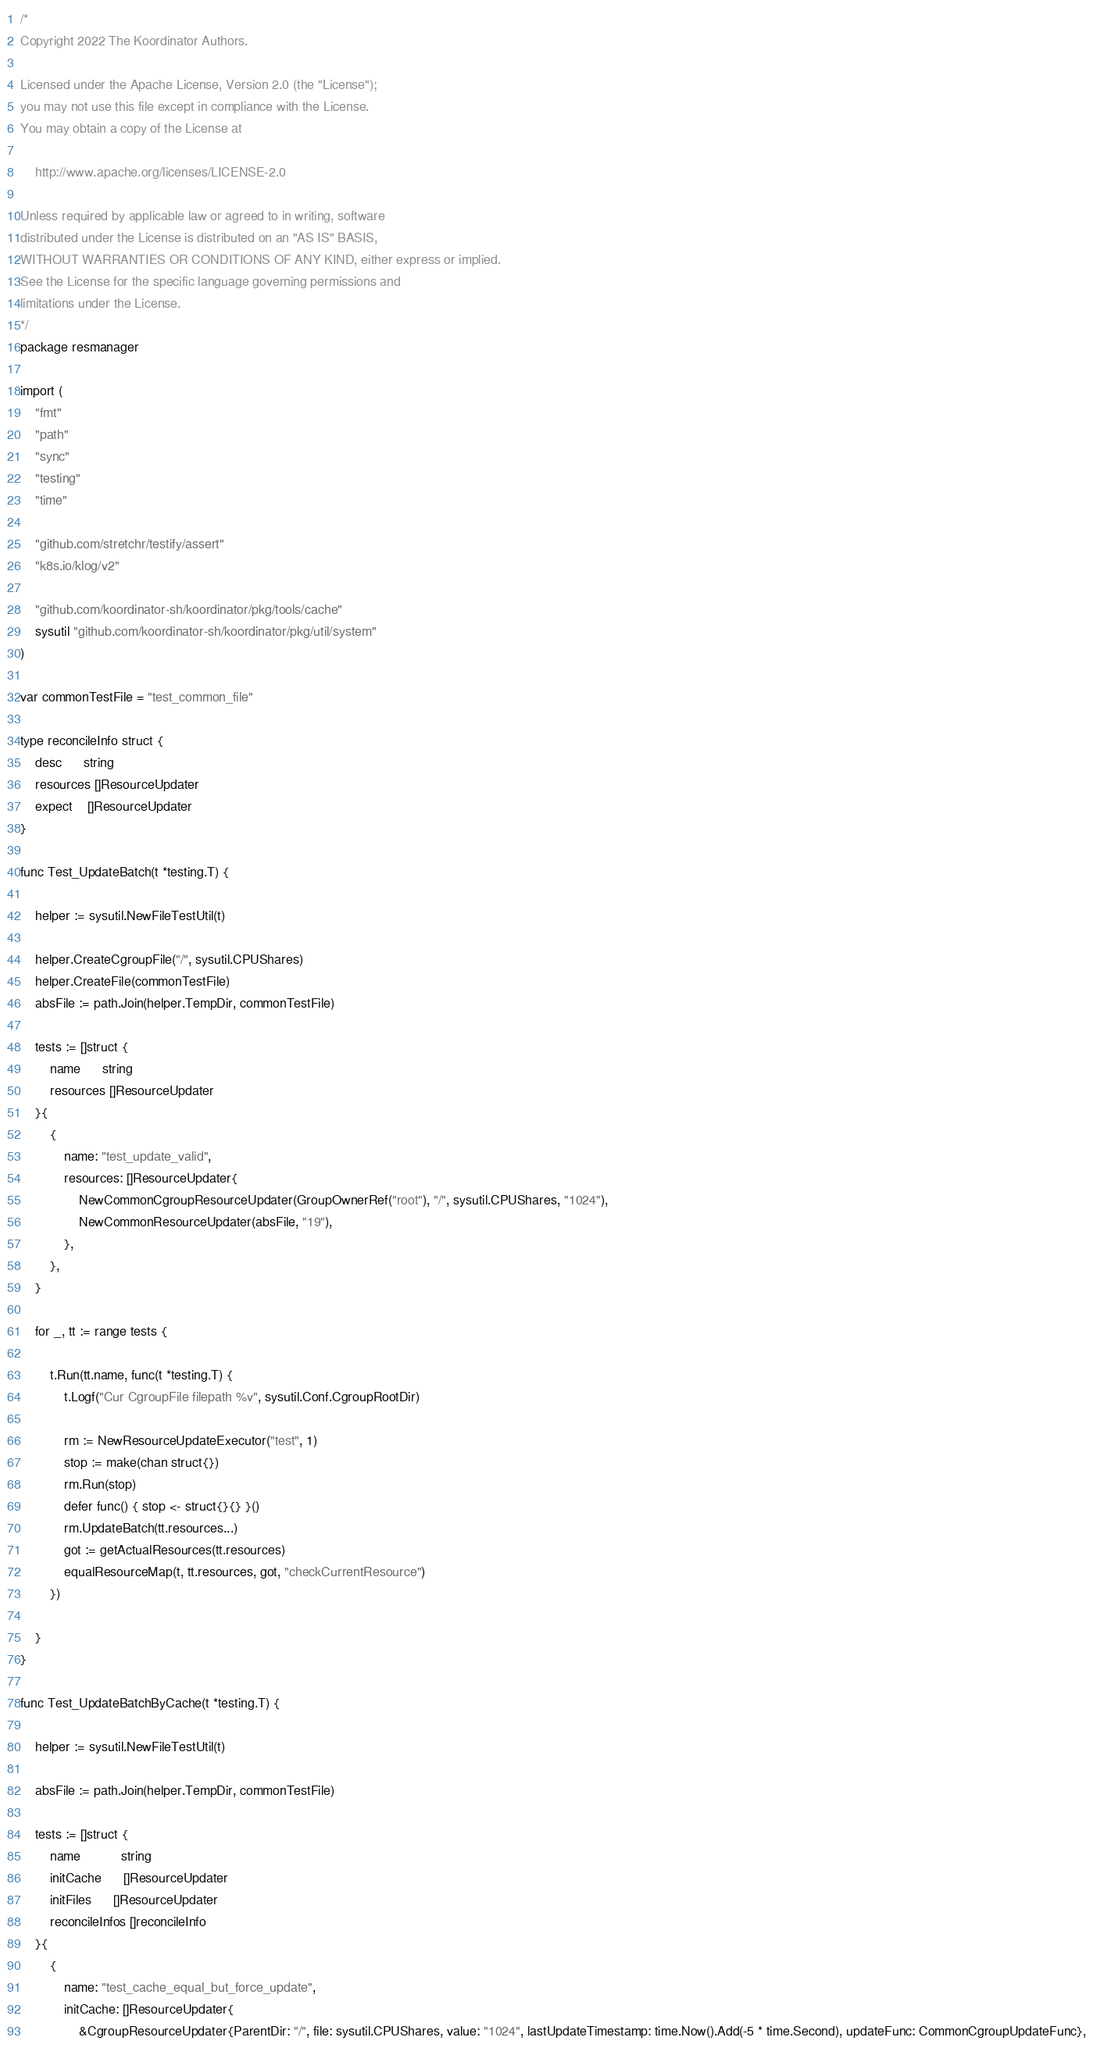<code> <loc_0><loc_0><loc_500><loc_500><_Go_>/*
Copyright 2022 The Koordinator Authors.

Licensed under the Apache License, Version 2.0 (the "License");
you may not use this file except in compliance with the License.
You may obtain a copy of the License at

    http://www.apache.org/licenses/LICENSE-2.0

Unless required by applicable law or agreed to in writing, software
distributed under the License is distributed on an "AS IS" BASIS,
WITHOUT WARRANTIES OR CONDITIONS OF ANY KIND, either express or implied.
See the License for the specific language governing permissions and
limitations under the License.
*/
package resmanager

import (
	"fmt"
	"path"
	"sync"
	"testing"
	"time"

	"github.com/stretchr/testify/assert"
	"k8s.io/klog/v2"

	"github.com/koordinator-sh/koordinator/pkg/tools/cache"
	sysutil "github.com/koordinator-sh/koordinator/pkg/util/system"
)

var commonTestFile = "test_common_file"

type reconcileInfo struct {
	desc      string
	resources []ResourceUpdater
	expect    []ResourceUpdater
}

func Test_UpdateBatch(t *testing.T) {

	helper := sysutil.NewFileTestUtil(t)

	helper.CreateCgroupFile("/", sysutil.CPUShares)
	helper.CreateFile(commonTestFile)
	absFile := path.Join(helper.TempDir, commonTestFile)

	tests := []struct {
		name      string
		resources []ResourceUpdater
	}{
		{
			name: "test_update_valid",
			resources: []ResourceUpdater{
				NewCommonCgroupResourceUpdater(GroupOwnerRef("root"), "/", sysutil.CPUShares, "1024"),
				NewCommonResourceUpdater(absFile, "19"),
			},
		},
	}

	for _, tt := range tests {

		t.Run(tt.name, func(t *testing.T) {
			t.Logf("Cur CgroupFile filepath %v", sysutil.Conf.CgroupRootDir)

			rm := NewResourceUpdateExecutor("test", 1)
			stop := make(chan struct{})
			rm.Run(stop)
			defer func() { stop <- struct{}{} }()
			rm.UpdateBatch(tt.resources...)
			got := getActualResources(tt.resources)
			equalResourceMap(t, tt.resources, got, "checkCurrentResource")
		})

	}
}

func Test_UpdateBatchByCache(t *testing.T) {

	helper := sysutil.NewFileTestUtil(t)

	absFile := path.Join(helper.TempDir, commonTestFile)

	tests := []struct {
		name           string
		initCache      []ResourceUpdater
		initFiles      []ResourceUpdater
		reconcileInfos []reconcileInfo
	}{
		{
			name: "test_cache_equal_but_force_update",
			initCache: []ResourceUpdater{
				&CgroupResourceUpdater{ParentDir: "/", file: sysutil.CPUShares, value: "1024", lastUpdateTimestamp: time.Now().Add(-5 * time.Second), updateFunc: CommonCgroupUpdateFunc},</code> 